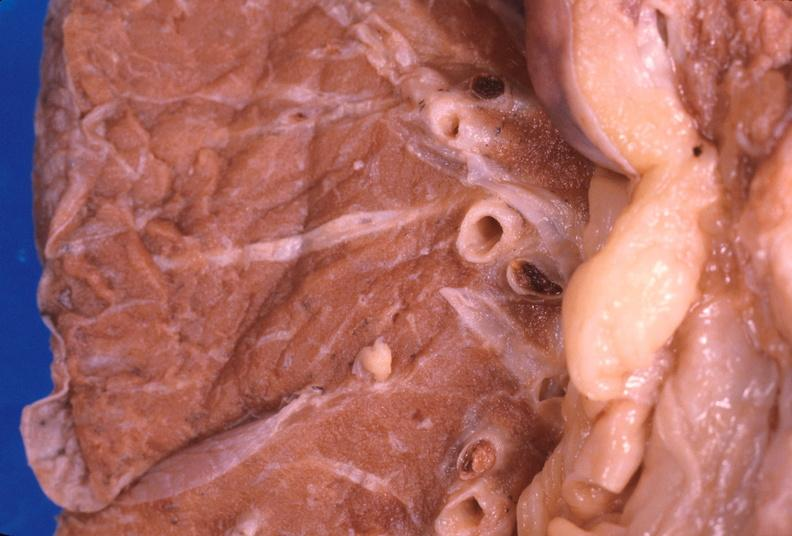where is this?
Answer the question using a single word or phrase. Lung 